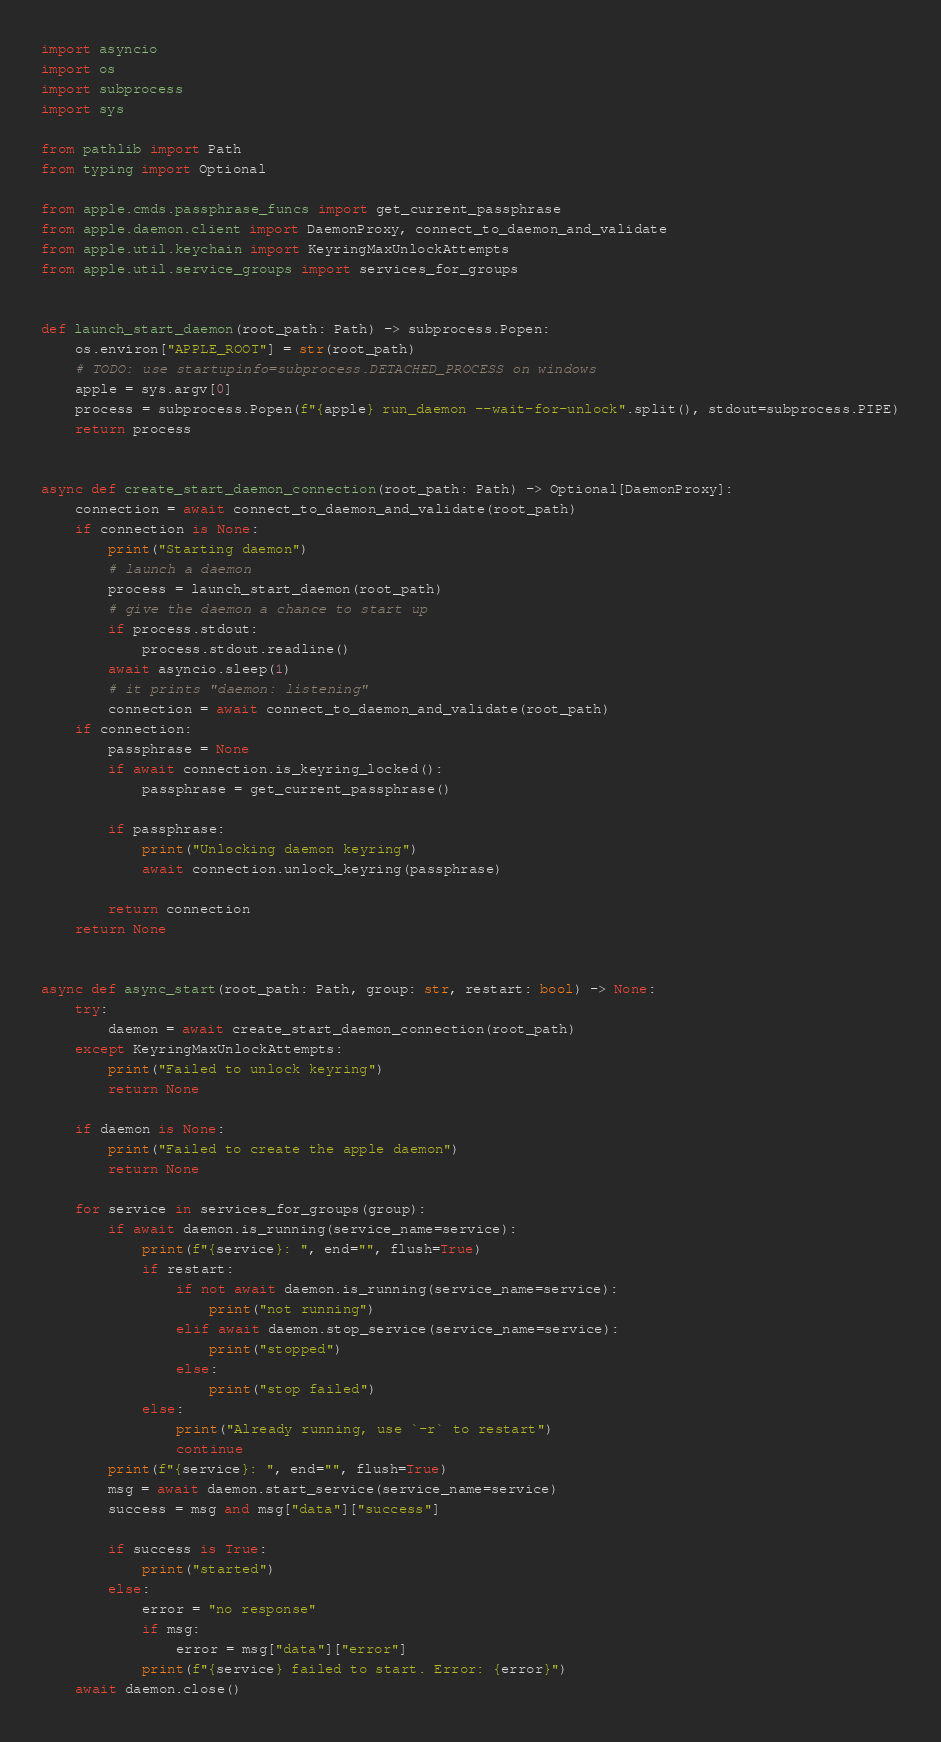<code> <loc_0><loc_0><loc_500><loc_500><_Python_>import asyncio
import os
import subprocess
import sys

from pathlib import Path
from typing import Optional

from apple.cmds.passphrase_funcs import get_current_passphrase
from apple.daemon.client import DaemonProxy, connect_to_daemon_and_validate
from apple.util.keychain import KeyringMaxUnlockAttempts
from apple.util.service_groups import services_for_groups


def launch_start_daemon(root_path: Path) -> subprocess.Popen:
    os.environ["APPLE_ROOT"] = str(root_path)
    # TODO: use startupinfo=subprocess.DETACHED_PROCESS on windows
    apple = sys.argv[0]
    process = subprocess.Popen(f"{apple} run_daemon --wait-for-unlock".split(), stdout=subprocess.PIPE)
    return process


async def create_start_daemon_connection(root_path: Path) -> Optional[DaemonProxy]:
    connection = await connect_to_daemon_and_validate(root_path)
    if connection is None:
        print("Starting daemon")
        # launch a daemon
        process = launch_start_daemon(root_path)
        # give the daemon a chance to start up
        if process.stdout:
            process.stdout.readline()
        await asyncio.sleep(1)
        # it prints "daemon: listening"
        connection = await connect_to_daemon_and_validate(root_path)
    if connection:
        passphrase = None
        if await connection.is_keyring_locked():
            passphrase = get_current_passphrase()

        if passphrase:
            print("Unlocking daemon keyring")
            await connection.unlock_keyring(passphrase)

        return connection
    return None


async def async_start(root_path: Path, group: str, restart: bool) -> None:
    try:
        daemon = await create_start_daemon_connection(root_path)
    except KeyringMaxUnlockAttempts:
        print("Failed to unlock keyring")
        return None

    if daemon is None:
        print("Failed to create the apple daemon")
        return None

    for service in services_for_groups(group):
        if await daemon.is_running(service_name=service):
            print(f"{service}: ", end="", flush=True)
            if restart:
                if not await daemon.is_running(service_name=service):
                    print("not running")
                elif await daemon.stop_service(service_name=service):
                    print("stopped")
                else:
                    print("stop failed")
            else:
                print("Already running, use `-r` to restart")
                continue
        print(f"{service}: ", end="", flush=True)
        msg = await daemon.start_service(service_name=service)
        success = msg and msg["data"]["success"]

        if success is True:
            print("started")
        else:
            error = "no response"
            if msg:
                error = msg["data"]["error"]
            print(f"{service} failed to start. Error: {error}")
    await daemon.close()
</code> 